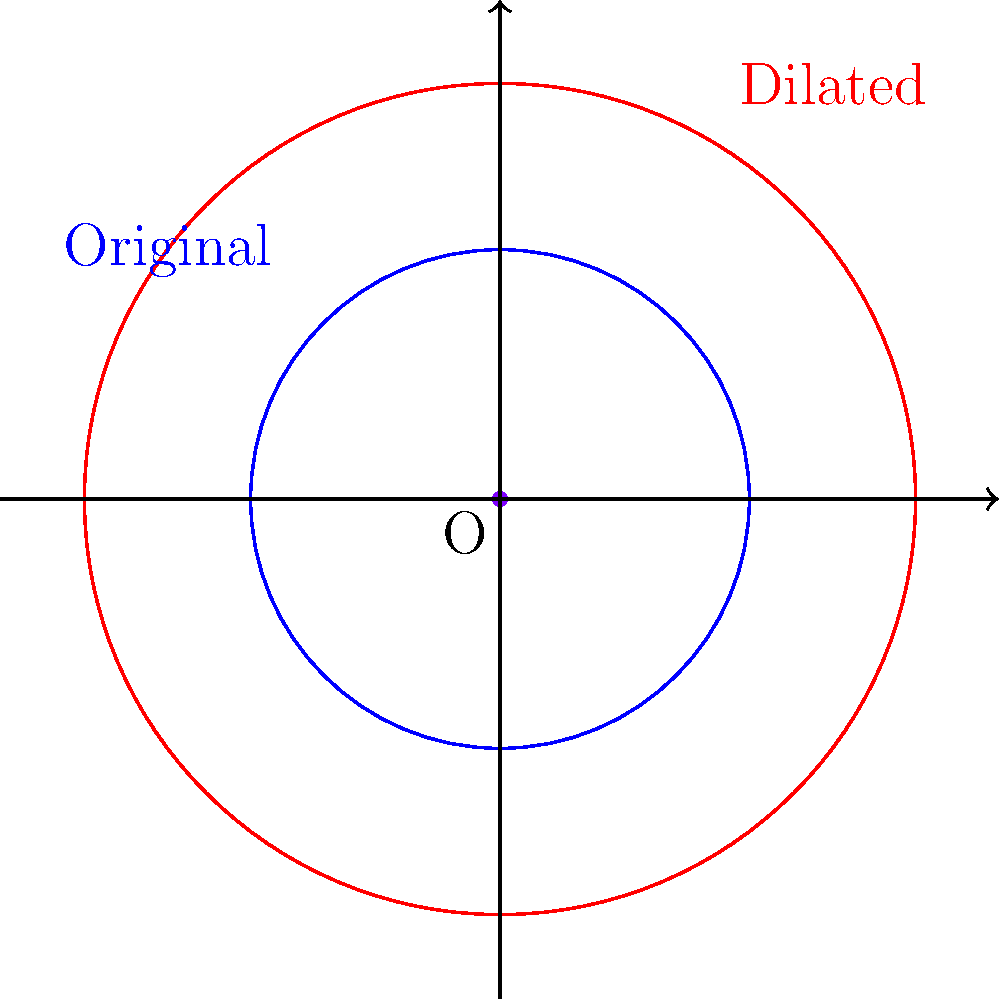As a retired engineer assisting with lighthouse maintenance, you're tasked with enhancing the radar coverage zone. The current circular coverage has a radius of 30 nautical miles. If you need to increase the coverage by a scale factor of 1.5 to improve maritime safety, what will be the new radius of the dilated coverage zone? To solve this problem, we'll use the concept of dilation in transformational geometry. Here's a step-by-step explanation:

1) The original radius of the radar coverage zone is 30 nautical miles.

2) We're asked to dilate this zone by a scale factor of 1.5.

3) In a dilation, all linear measurements are multiplied by the scale factor.

4) Therefore, to find the new radius, we multiply the original radius by the scale factor:

   $$ \text{New Radius} = \text{Original Radius} \times \text{Scale Factor} $$
   $$ \text{New Radius} = 30 \times 1.5 $$
   $$ \text{New Radius} = 45 \text{ nautical miles} $$

5) Thus, the radius of the dilated coverage zone will be 45 nautical miles.

This dilation will increase the area of coverage significantly, enhancing maritime safety in a larger region around the lighthouse.
Answer: 45 nautical miles 